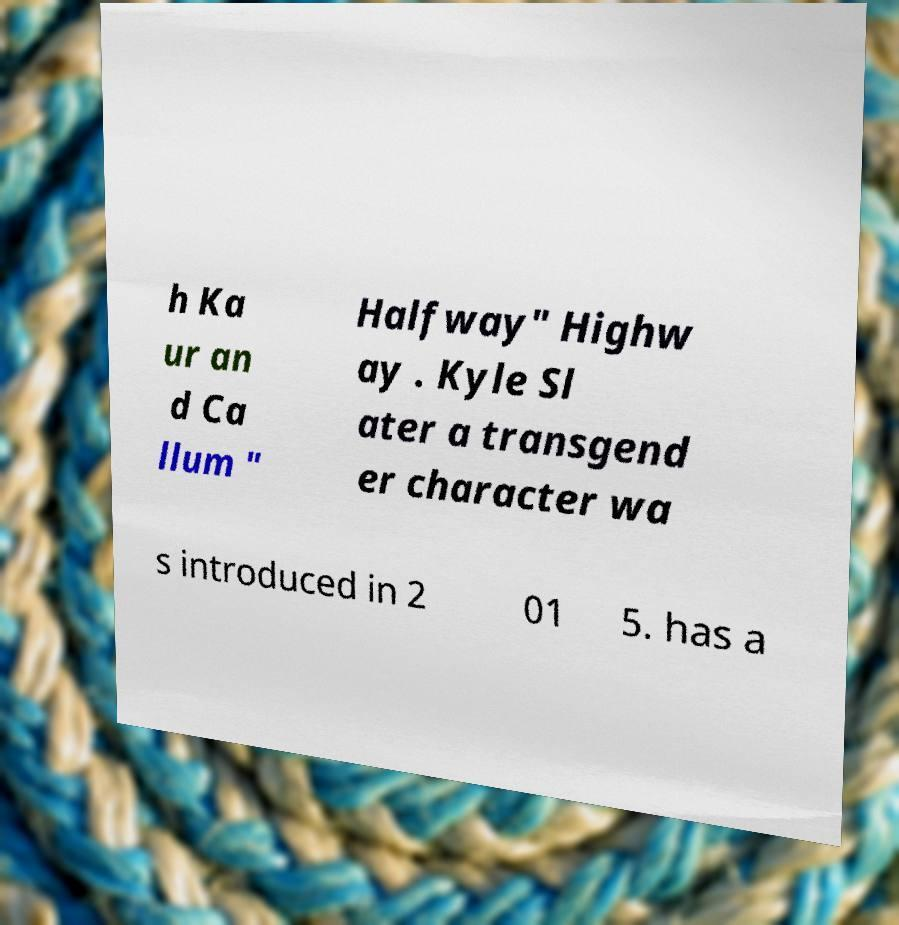Please read and relay the text visible in this image. What does it say? h Ka ur an d Ca llum " Halfway" Highw ay . Kyle Sl ater a transgend er character wa s introduced in 2 01 5. has a 